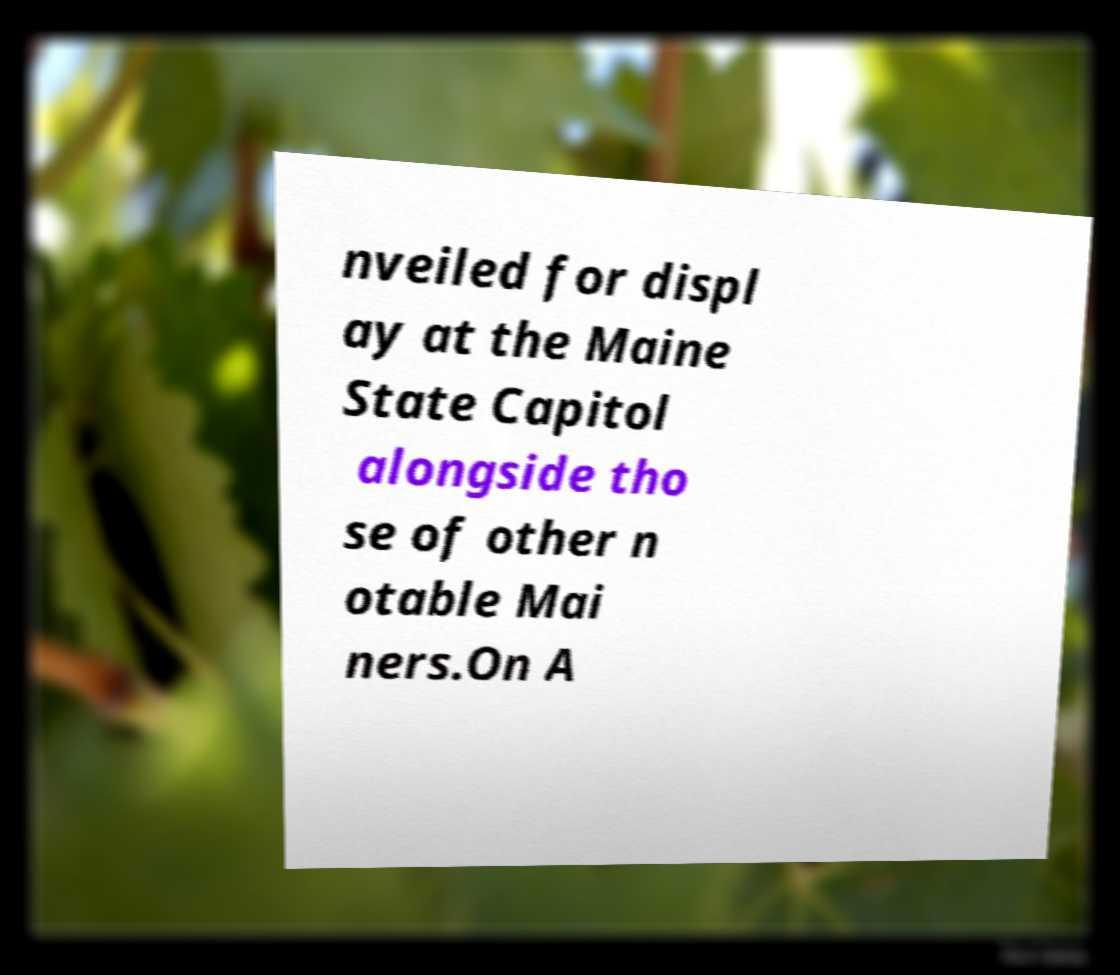Please identify and transcribe the text found in this image. nveiled for displ ay at the Maine State Capitol alongside tho se of other n otable Mai ners.On A 